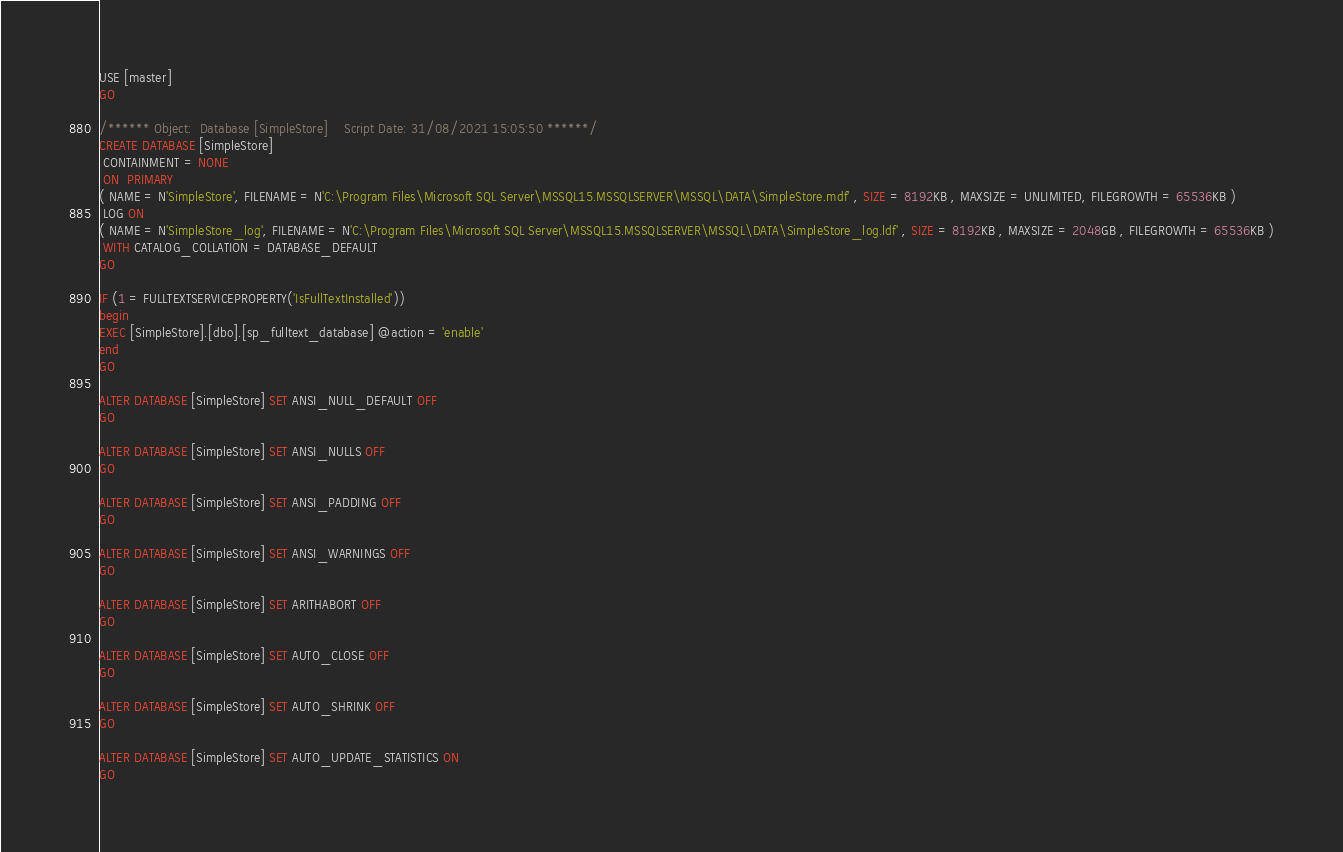Convert code to text. <code><loc_0><loc_0><loc_500><loc_500><_SQL_>USE [master]
GO

/****** Object:  Database [SimpleStore]    Script Date: 31/08/2021 15:05:50 ******/
CREATE DATABASE [SimpleStore]
 CONTAINMENT = NONE
 ON  PRIMARY 
( NAME = N'SimpleStore', FILENAME = N'C:\Program Files\Microsoft SQL Server\MSSQL15.MSSQLSERVER\MSSQL\DATA\SimpleStore.mdf' , SIZE = 8192KB , MAXSIZE = UNLIMITED, FILEGROWTH = 65536KB )
 LOG ON 
( NAME = N'SimpleStore_log', FILENAME = N'C:\Program Files\Microsoft SQL Server\MSSQL15.MSSQLSERVER\MSSQL\DATA\SimpleStore_log.ldf' , SIZE = 8192KB , MAXSIZE = 2048GB , FILEGROWTH = 65536KB )
 WITH CATALOG_COLLATION = DATABASE_DEFAULT
GO

IF (1 = FULLTEXTSERVICEPROPERTY('IsFullTextInstalled'))
begin
EXEC [SimpleStore].[dbo].[sp_fulltext_database] @action = 'enable'
end
GO

ALTER DATABASE [SimpleStore] SET ANSI_NULL_DEFAULT OFF 
GO

ALTER DATABASE [SimpleStore] SET ANSI_NULLS OFF 
GO

ALTER DATABASE [SimpleStore] SET ANSI_PADDING OFF 
GO

ALTER DATABASE [SimpleStore] SET ANSI_WARNINGS OFF 
GO

ALTER DATABASE [SimpleStore] SET ARITHABORT OFF 
GO

ALTER DATABASE [SimpleStore] SET AUTO_CLOSE OFF 
GO

ALTER DATABASE [SimpleStore] SET AUTO_SHRINK OFF 
GO

ALTER DATABASE [SimpleStore] SET AUTO_UPDATE_STATISTICS ON 
GO
</code> 